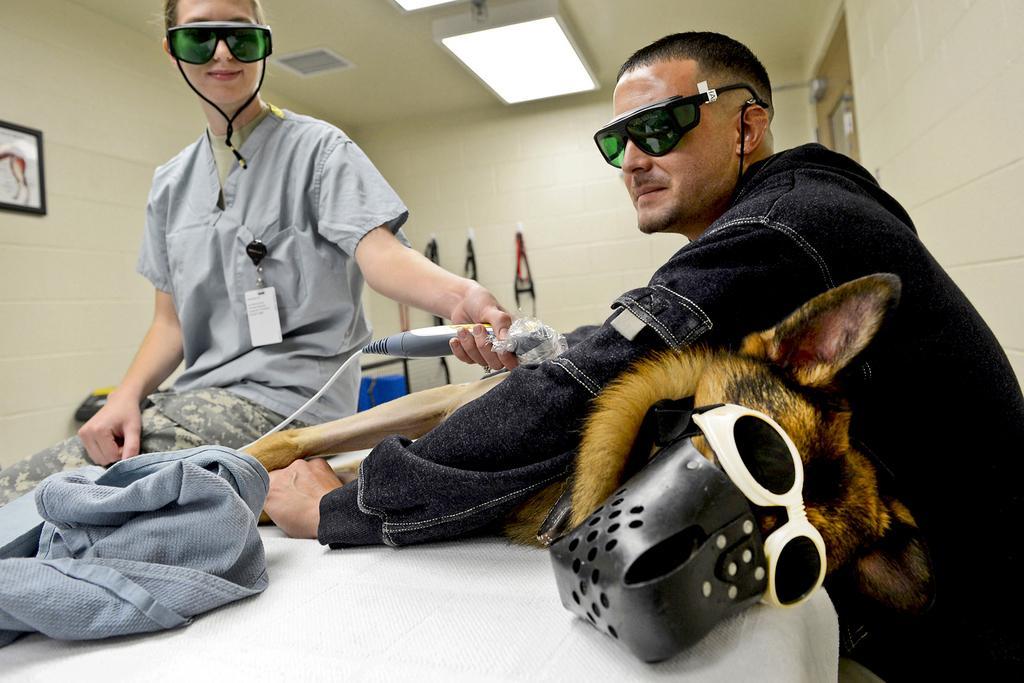Describe this image in one or two sentences. In the front of the image there are people, cloth, table, dog and object. One person is holding a dog and another person is holding an object. Two people wore goggles. In the background of the image there are lights, wall, picture and objects. Picture is on the wall.   